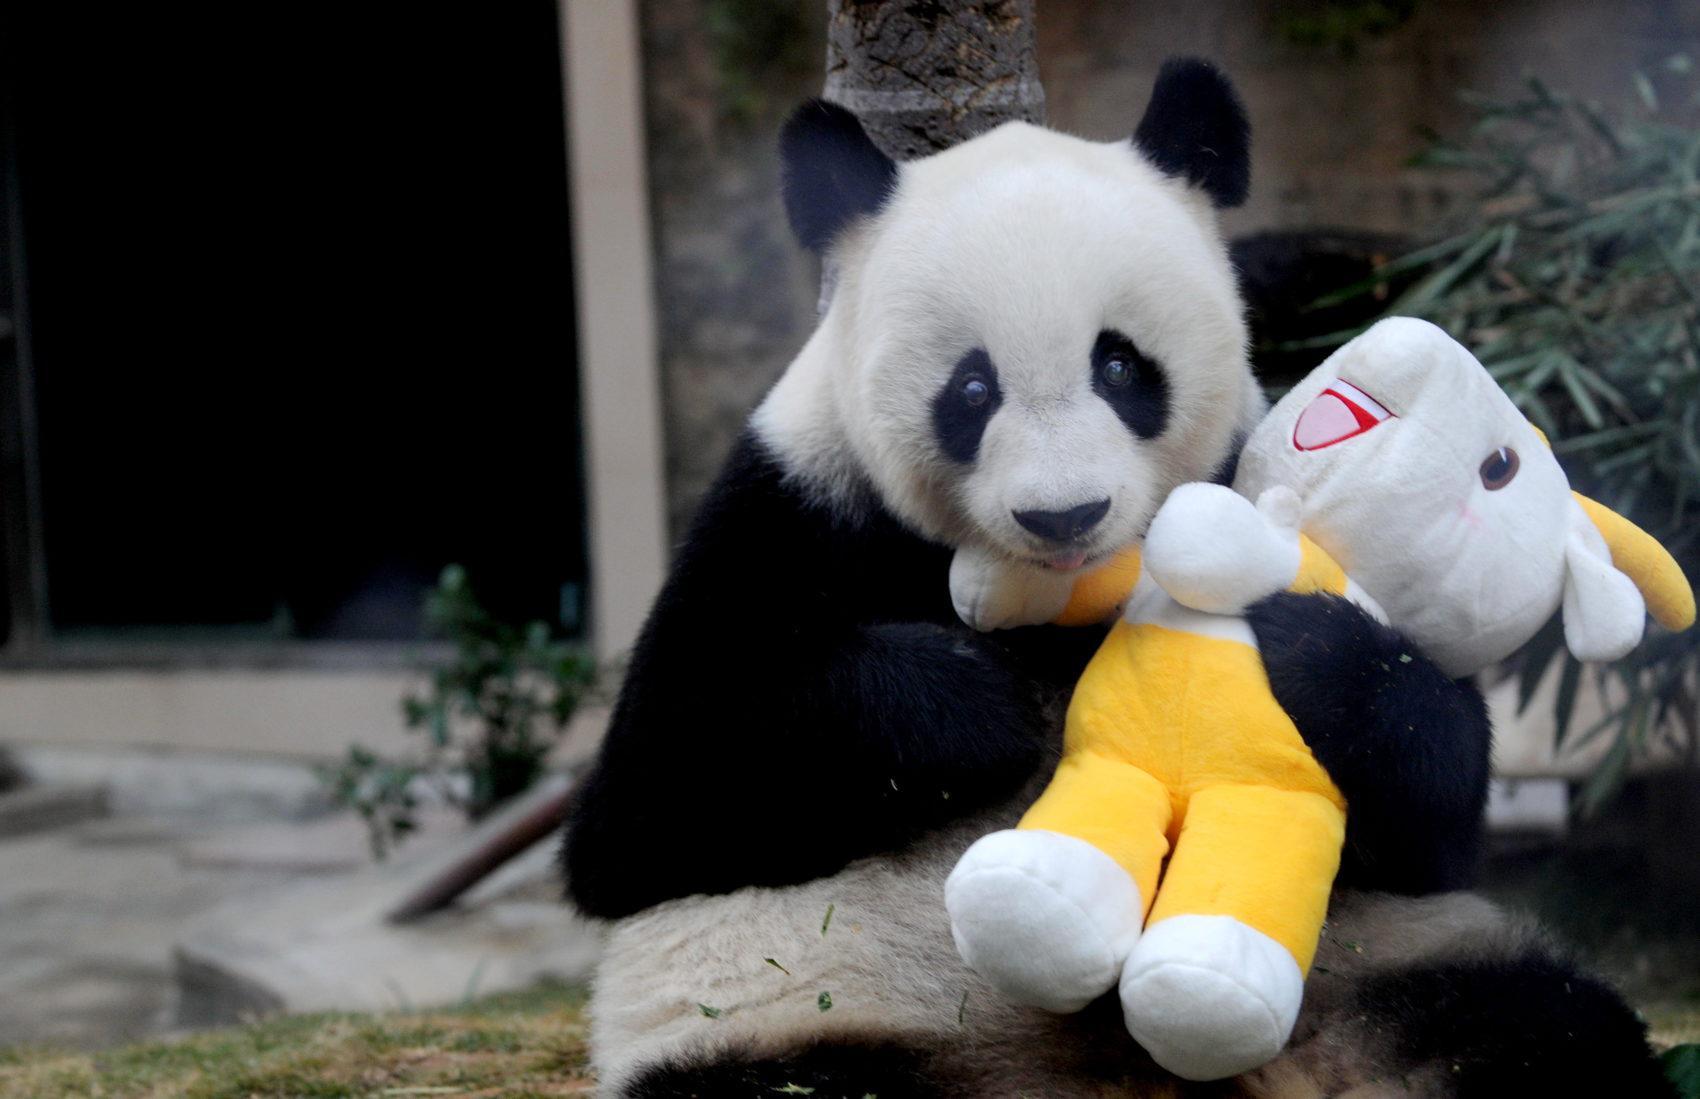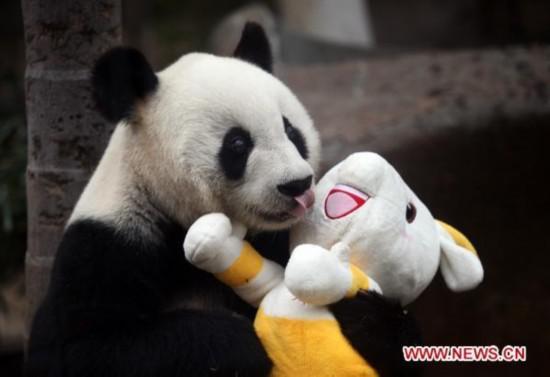The first image is the image on the left, the second image is the image on the right. Considering the images on both sides, is "The combined images include a dark-haired woman and a panda wearing a red-and-gold crown." valid? Answer yes or no. No. The first image is the image on the left, the second image is the image on the right. For the images displayed, is the sentence "The panda in the image on the right is wearing a hat." factually correct? Answer yes or no. No. 